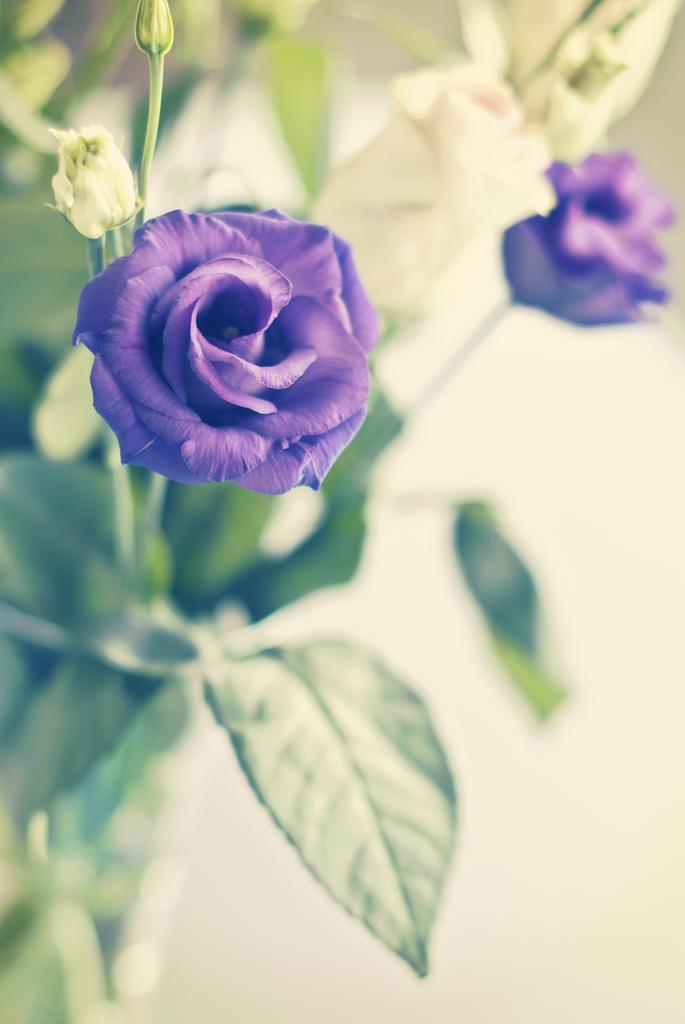Can you describe this image briefly? There are two flowers on a plant as we can see in the middle of this image. 